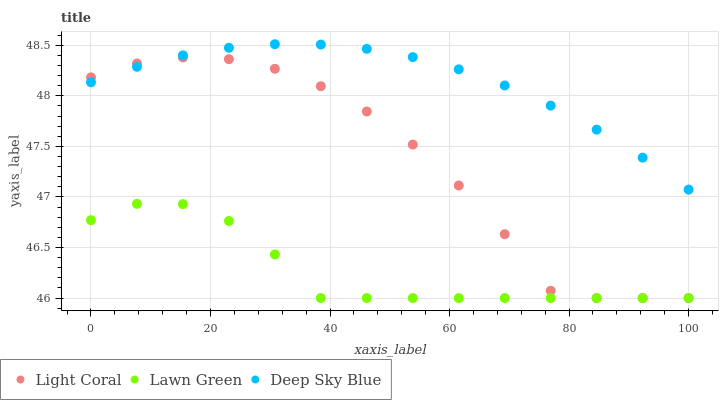Does Lawn Green have the minimum area under the curve?
Answer yes or no. Yes. Does Deep Sky Blue have the maximum area under the curve?
Answer yes or no. Yes. Does Deep Sky Blue have the minimum area under the curve?
Answer yes or no. No. Does Lawn Green have the maximum area under the curve?
Answer yes or no. No. Is Deep Sky Blue the smoothest?
Answer yes or no. Yes. Is Light Coral the roughest?
Answer yes or no. Yes. Is Lawn Green the smoothest?
Answer yes or no. No. Is Lawn Green the roughest?
Answer yes or no. No. Does Light Coral have the lowest value?
Answer yes or no. Yes. Does Deep Sky Blue have the lowest value?
Answer yes or no. No. Does Deep Sky Blue have the highest value?
Answer yes or no. Yes. Does Lawn Green have the highest value?
Answer yes or no. No. Is Lawn Green less than Deep Sky Blue?
Answer yes or no. Yes. Is Deep Sky Blue greater than Lawn Green?
Answer yes or no. Yes. Does Light Coral intersect Lawn Green?
Answer yes or no. Yes. Is Light Coral less than Lawn Green?
Answer yes or no. No. Is Light Coral greater than Lawn Green?
Answer yes or no. No. Does Lawn Green intersect Deep Sky Blue?
Answer yes or no. No. 